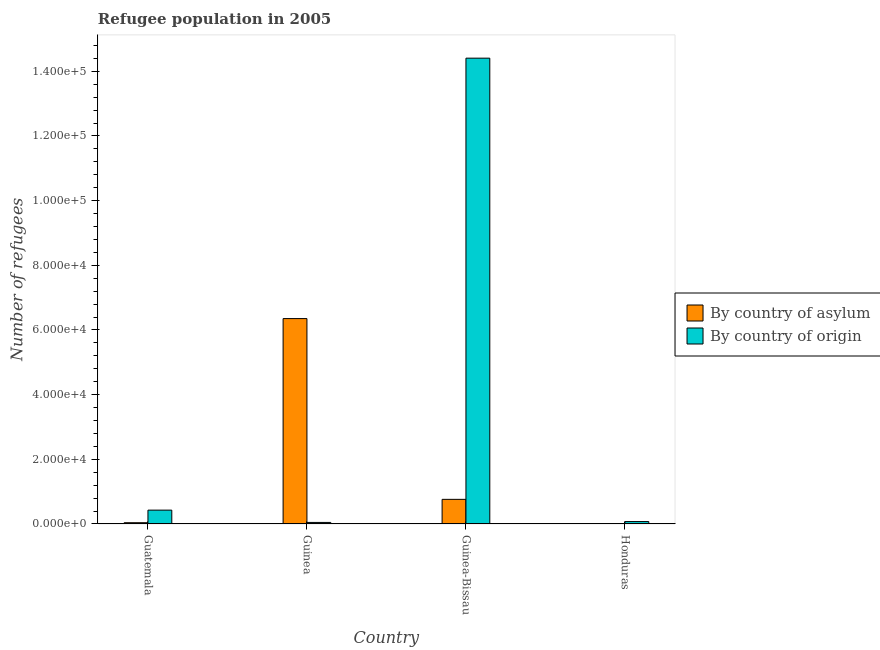How many different coloured bars are there?
Your response must be concise. 2. Are the number of bars per tick equal to the number of legend labels?
Offer a very short reply. Yes. How many bars are there on the 1st tick from the left?
Keep it short and to the point. 2. How many bars are there on the 4th tick from the right?
Offer a very short reply. 2. What is the label of the 2nd group of bars from the left?
Give a very brief answer. Guinea. In how many cases, is the number of bars for a given country not equal to the number of legend labels?
Your answer should be compact. 0. What is the number of refugees by country of asylum in Guatemala?
Your answer should be very brief. 391. Across all countries, what is the maximum number of refugees by country of origin?
Your answer should be very brief. 1.44e+05. Across all countries, what is the minimum number of refugees by country of origin?
Provide a succinct answer. 477. In which country was the number of refugees by country of asylum maximum?
Provide a succinct answer. Guinea. In which country was the number of refugees by country of origin minimum?
Your response must be concise. Guinea. What is the total number of refugees by country of asylum in the graph?
Your response must be concise. 7.16e+04. What is the difference between the number of refugees by country of asylum in Guinea and that in Honduras?
Your response must be concise. 6.35e+04. What is the difference between the number of refugees by country of asylum in Honduras and the number of refugees by country of origin in Guinea-Bissau?
Give a very brief answer. -1.44e+05. What is the average number of refugees by country of origin per country?
Keep it short and to the point. 3.74e+04. What is the difference between the number of refugees by country of origin and number of refugees by country of asylum in Honduras?
Your answer should be compact. 721. In how many countries, is the number of refugees by country of origin greater than 16000 ?
Provide a short and direct response. 1. What is the ratio of the number of refugees by country of origin in Guatemala to that in Honduras?
Provide a succinct answer. 5.76. What is the difference between the highest and the second highest number of refugees by country of asylum?
Provide a short and direct response. 5.59e+04. What is the difference between the highest and the lowest number of refugees by country of asylum?
Ensure brevity in your answer.  6.35e+04. What does the 1st bar from the left in Guinea represents?
Your response must be concise. By country of asylum. What does the 2nd bar from the right in Guinea-Bissau represents?
Provide a short and direct response. By country of asylum. Are all the bars in the graph horizontal?
Offer a terse response. No. What is the difference between two consecutive major ticks on the Y-axis?
Your answer should be very brief. 2.00e+04. Are the values on the major ticks of Y-axis written in scientific E-notation?
Ensure brevity in your answer.  Yes. Does the graph contain grids?
Your answer should be very brief. No. How many legend labels are there?
Make the answer very short. 2. How are the legend labels stacked?
Provide a short and direct response. Vertical. What is the title of the graph?
Your response must be concise. Refugee population in 2005. Does "Males" appear as one of the legend labels in the graph?
Keep it short and to the point. No. What is the label or title of the Y-axis?
Provide a short and direct response. Number of refugees. What is the Number of refugees of By country of asylum in Guatemala?
Provide a succinct answer. 391. What is the Number of refugees in By country of origin in Guatemala?
Offer a very short reply. 4281. What is the Number of refugees of By country of asylum in Guinea?
Your answer should be very brief. 6.35e+04. What is the Number of refugees in By country of origin in Guinea?
Your response must be concise. 477. What is the Number of refugees in By country of asylum in Guinea-Bissau?
Your answer should be very brief. 7616. What is the Number of refugees of By country of origin in Guinea-Bissau?
Your response must be concise. 1.44e+05. What is the Number of refugees of By country of asylum in Honduras?
Ensure brevity in your answer.  22. What is the Number of refugees of By country of origin in Honduras?
Give a very brief answer. 743. Across all countries, what is the maximum Number of refugees of By country of asylum?
Your answer should be compact. 6.35e+04. Across all countries, what is the maximum Number of refugees of By country of origin?
Keep it short and to the point. 1.44e+05. Across all countries, what is the minimum Number of refugees in By country of asylum?
Make the answer very short. 22. Across all countries, what is the minimum Number of refugees of By country of origin?
Provide a short and direct response. 477. What is the total Number of refugees of By country of asylum in the graph?
Offer a very short reply. 7.16e+04. What is the total Number of refugees in By country of origin in the graph?
Give a very brief answer. 1.50e+05. What is the difference between the Number of refugees in By country of asylum in Guatemala and that in Guinea?
Offer a very short reply. -6.31e+04. What is the difference between the Number of refugees of By country of origin in Guatemala and that in Guinea?
Keep it short and to the point. 3804. What is the difference between the Number of refugees of By country of asylum in Guatemala and that in Guinea-Bissau?
Give a very brief answer. -7225. What is the difference between the Number of refugees of By country of origin in Guatemala and that in Guinea-Bissau?
Make the answer very short. -1.40e+05. What is the difference between the Number of refugees in By country of asylum in Guatemala and that in Honduras?
Keep it short and to the point. 369. What is the difference between the Number of refugees of By country of origin in Guatemala and that in Honduras?
Offer a very short reply. 3538. What is the difference between the Number of refugees in By country of asylum in Guinea and that in Guinea-Bissau?
Keep it short and to the point. 5.59e+04. What is the difference between the Number of refugees of By country of origin in Guinea and that in Guinea-Bissau?
Offer a very short reply. -1.44e+05. What is the difference between the Number of refugees in By country of asylum in Guinea and that in Honduras?
Offer a terse response. 6.35e+04. What is the difference between the Number of refugees of By country of origin in Guinea and that in Honduras?
Give a very brief answer. -266. What is the difference between the Number of refugees in By country of asylum in Guinea-Bissau and that in Honduras?
Provide a succinct answer. 7594. What is the difference between the Number of refugees in By country of origin in Guinea-Bissau and that in Honduras?
Your response must be concise. 1.43e+05. What is the difference between the Number of refugees of By country of asylum in Guatemala and the Number of refugees of By country of origin in Guinea?
Give a very brief answer. -86. What is the difference between the Number of refugees of By country of asylum in Guatemala and the Number of refugees of By country of origin in Guinea-Bissau?
Your response must be concise. -1.44e+05. What is the difference between the Number of refugees in By country of asylum in Guatemala and the Number of refugees in By country of origin in Honduras?
Ensure brevity in your answer.  -352. What is the difference between the Number of refugees in By country of asylum in Guinea and the Number of refugees in By country of origin in Guinea-Bissau?
Provide a short and direct response. -8.05e+04. What is the difference between the Number of refugees of By country of asylum in Guinea and the Number of refugees of By country of origin in Honduras?
Give a very brief answer. 6.28e+04. What is the difference between the Number of refugees in By country of asylum in Guinea-Bissau and the Number of refugees in By country of origin in Honduras?
Your answer should be very brief. 6873. What is the average Number of refugees in By country of asylum per country?
Provide a succinct answer. 1.79e+04. What is the average Number of refugees in By country of origin per country?
Your response must be concise. 3.74e+04. What is the difference between the Number of refugees of By country of asylum and Number of refugees of By country of origin in Guatemala?
Provide a short and direct response. -3890. What is the difference between the Number of refugees of By country of asylum and Number of refugees of By country of origin in Guinea?
Ensure brevity in your answer.  6.30e+04. What is the difference between the Number of refugees of By country of asylum and Number of refugees of By country of origin in Guinea-Bissau?
Provide a short and direct response. -1.36e+05. What is the difference between the Number of refugees of By country of asylum and Number of refugees of By country of origin in Honduras?
Your answer should be very brief. -721. What is the ratio of the Number of refugees of By country of asylum in Guatemala to that in Guinea?
Provide a short and direct response. 0.01. What is the ratio of the Number of refugees in By country of origin in Guatemala to that in Guinea?
Your answer should be compact. 8.97. What is the ratio of the Number of refugees of By country of asylum in Guatemala to that in Guinea-Bissau?
Provide a succinct answer. 0.05. What is the ratio of the Number of refugees in By country of origin in Guatemala to that in Guinea-Bissau?
Your answer should be compact. 0.03. What is the ratio of the Number of refugees of By country of asylum in Guatemala to that in Honduras?
Ensure brevity in your answer.  17.77. What is the ratio of the Number of refugees of By country of origin in Guatemala to that in Honduras?
Provide a short and direct response. 5.76. What is the ratio of the Number of refugees in By country of asylum in Guinea to that in Guinea-Bissau?
Make the answer very short. 8.34. What is the ratio of the Number of refugees of By country of origin in Guinea to that in Guinea-Bissau?
Ensure brevity in your answer.  0. What is the ratio of the Number of refugees in By country of asylum in Guinea to that in Honduras?
Provide a short and direct response. 2887.5. What is the ratio of the Number of refugees of By country of origin in Guinea to that in Honduras?
Offer a terse response. 0.64. What is the ratio of the Number of refugees of By country of asylum in Guinea-Bissau to that in Honduras?
Your answer should be very brief. 346.18. What is the ratio of the Number of refugees in By country of origin in Guinea-Bissau to that in Honduras?
Make the answer very short. 193.9. What is the difference between the highest and the second highest Number of refugees of By country of asylum?
Provide a succinct answer. 5.59e+04. What is the difference between the highest and the second highest Number of refugees of By country of origin?
Provide a short and direct response. 1.40e+05. What is the difference between the highest and the lowest Number of refugees in By country of asylum?
Your answer should be very brief. 6.35e+04. What is the difference between the highest and the lowest Number of refugees in By country of origin?
Keep it short and to the point. 1.44e+05. 